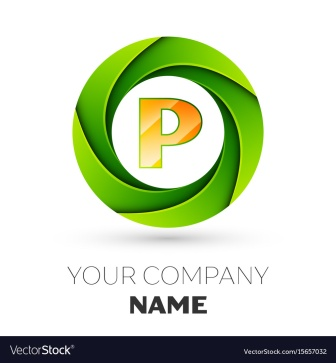Can you describe the color scheme used in this logo and what emotions they might evoke? The logo utilizes a contrasting color scheme with a vibrant green and a warm orange. Green often evokes feelings of growth, health, and freshness, making it a popular choice for brands looking to project an image of vitality and innovation. Orange, on the other hand, is associated with creativity, enthusiasm, and energy. The combination of these colors in this logo can create a lively and dynamic feeling, appealing to a youthful, energetic audience. 